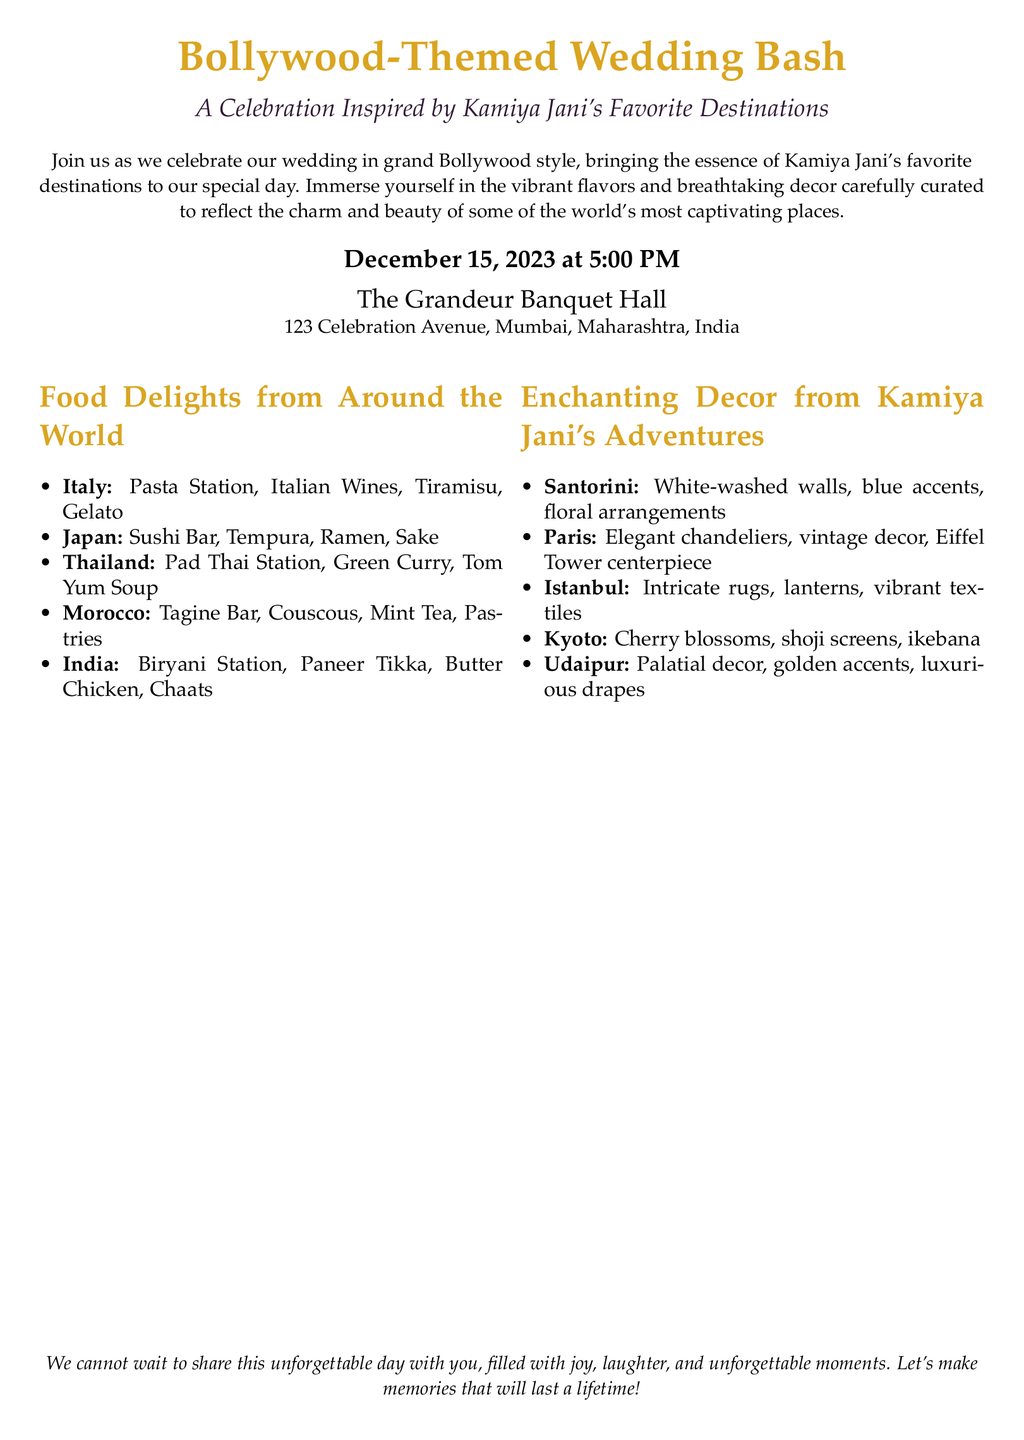what is the wedding date? The wedding date is explicitly mentioned in the document as December 15, 2023.
Answer: December 15, 2023 what is the venue for the wedding? The venue for the wedding is stated as The Grandeur Banquet Hall, located at 123 Celebration Avenue, Mumbai, Maharashtra, India.
Answer: The Grandeur Banquet Hall which cuisine has a Tiramisu dessert? The cuisine associated with Tiramisu is identified in the food section as Italian.
Answer: Italian which destination features cherry blossoms in the decor? Cherry blossoms are mentioned under the decor inspired by Kyoto.
Answer: Kyoto what type of drink is listed under the Japan cuisine? The drink that is listed under the Japan cuisine is Sake.
Answer: Sake how many different international cuisines are mentioned? The document lists a total of five different international cuisines in the food section.
Answer: Five what kind of accents are featured in the Santorini decor? The Santorini decor features blue accents alongside white-washed walls.
Answer: Blue accents which city is associated with elegant chandeliers? The city associated with elegant chandeliers is Paris.
Answer: Paris what is the primary theme of the wedding? The primary theme of the wedding is a Bollywood-Themed Wedding Bash.
Answer: Bollywood-Themed Wedding Bash 